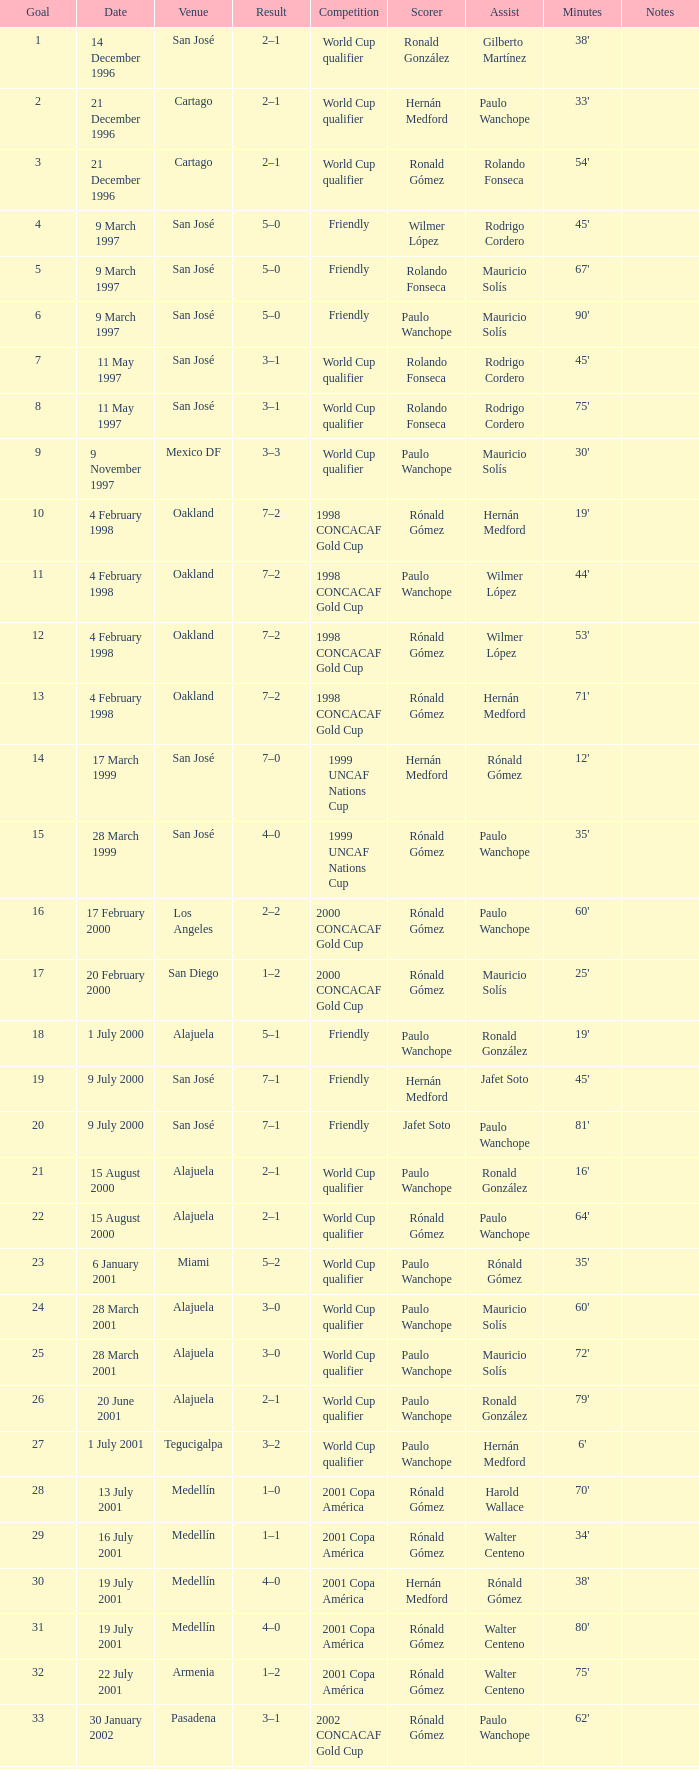What is the result in oakland? 7–2, 7–2, 7–2, 7–2. 